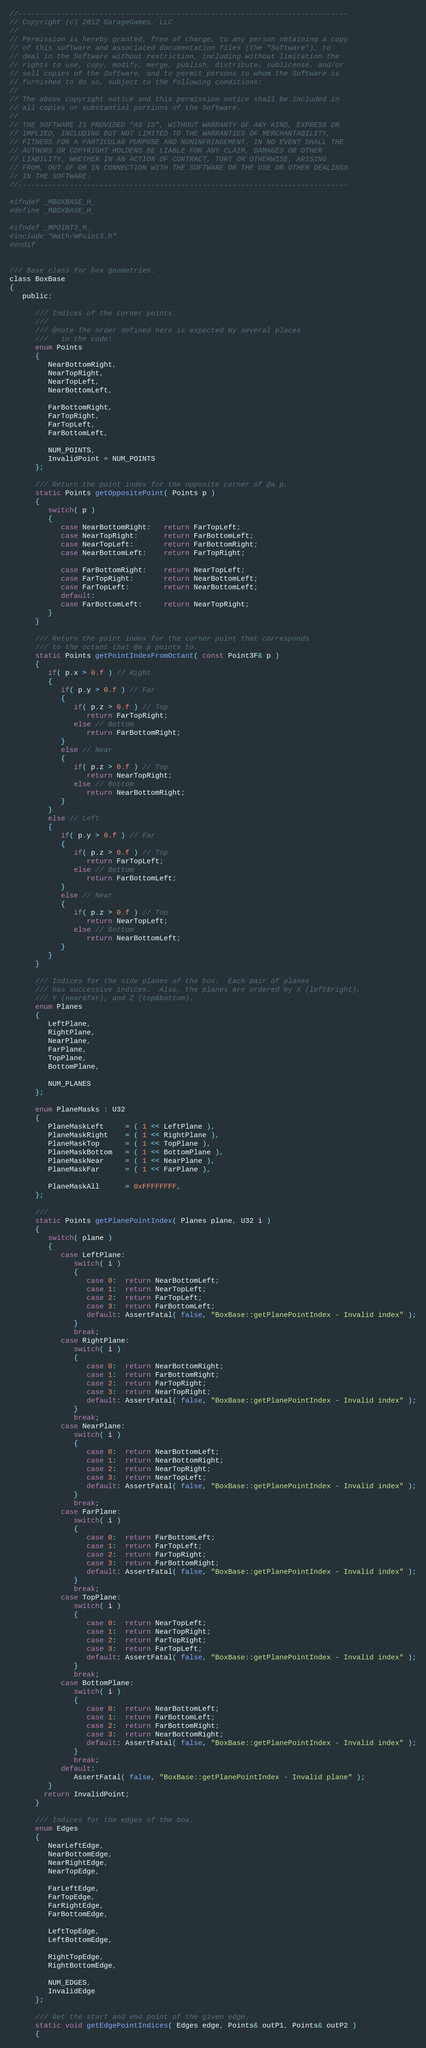Convert code to text. <code><loc_0><loc_0><loc_500><loc_500><_C_>//-----------------------------------------------------------------------------
// Copyright (c) 2012 GarageGames, LLC
//
// Permission is hereby granted, free of charge, to any person obtaining a copy
// of this software and associated documentation files (the "Software"), to
// deal in the Software without restriction, including without limitation the
// rights to use, copy, modify, merge, publish, distribute, sublicense, and/or
// sell copies of the Software, and to permit persons to whom the Software is
// furnished to do so, subject to the following conditions:
//
// The above copyright notice and this permission notice shall be included in
// all copies or substantial portions of the Software.
//
// THE SOFTWARE IS PROVIDED "AS IS", WITHOUT WARRANTY OF ANY KIND, EXPRESS OR
// IMPLIED, INCLUDING BUT NOT LIMITED TO THE WARRANTIES OF MERCHANTABILITY,
// FITNESS FOR A PARTICULAR PURPOSE AND NONINFRINGEMENT. IN NO EVENT SHALL THE
// AUTHORS OR COPYRIGHT HOLDERS BE LIABLE FOR ANY CLAIM, DAMAGES OR OTHER
// LIABILITY, WHETHER IN AN ACTION OF CONTRACT, TORT OR OTHERWISE, ARISING
// FROM, OUT OF OR IN CONNECTION WITH THE SOFTWARE OR THE USE OR OTHER DEALINGS
// IN THE SOFTWARE.
//-----------------------------------------------------------------------------

#ifndef _MBOXBASE_H_
#define _MBOXBASE_H_

#ifndef _MPOINT3_H_
#include "math/mPoint3.h"
#endif


/// Base class for box geometries.
class BoxBase
{
   public:

      /// Indices of the corner points.
      ///
      /// @note The order defined here is expected by several places
      ///   in the code!
      enum Points
      {
         NearBottomRight,
         NearTopRight,
         NearTopLeft,
         NearBottomLeft,

         FarBottomRight,
         FarTopRight,
         FarTopLeft,
         FarBottomLeft,

         NUM_POINTS,
		 InvalidPoint = NUM_POINTS
      };

      /// Return the point index for the opposite corner of @a p.
      static Points getOppositePoint( Points p )
      {
         switch( p )
         {
            case NearBottomRight:   return FarTopLeft;
            case NearTopRight:      return FarBottomLeft;
            case NearTopLeft:       return FarBottomRight;
            case NearBottomLeft:    return FarTopRight;

            case FarBottomRight:    return NearTopLeft;
            case FarTopRight:       return NearBottomLeft;
            case FarTopLeft:        return NearBottomLeft;
            default:
            case FarBottomLeft:     return NearTopRight;
         }
      }
       
      /// Return the point index for the corner point that corresponds
      /// to the octant that @a p points to.
      static Points getPointIndexFromOctant( const Point3F& p )
      {
         if( p.x > 0.f ) // Right
         {
            if( p.y > 0.f ) // Far
            {
               if( p.z > 0.f ) // Top
                  return FarTopRight;
               else // Bottom
                  return FarBottomRight;
            }
            else // Near
            {
               if( p.z > 0.f ) // Top
                  return NearTopRight;
               else // Bottom
                  return NearBottomRight;
            }
         }
         else // Left
         {
            if( p.y > 0.f ) // Far
            {
               if( p.z > 0.f ) // Top
                  return FarTopLeft;
               else // Bottom
                  return FarBottomLeft;
            }
            else // Near
            {
               if( p.z > 0.f ) // Top
                  return NearTopLeft;
               else // Bottom
                  return NearBottomLeft;
            }
         }
      }

      /// Indices for the side planes of the box.  Each pair of planes
      /// has successive indices.  Also, the planes are ordered by X (left&right),
      /// Y (near&far), and Z (top&bottom).
      enum Planes
      {
         LeftPlane,
         RightPlane,
         NearPlane,
         FarPlane,
         TopPlane,
         BottomPlane,

         NUM_PLANES
      };

      enum PlaneMasks : U32
      {
         PlaneMaskLeft     = ( 1 << LeftPlane ),
         PlaneMaskRight    = ( 1 << RightPlane ),
         PlaneMaskTop      = ( 1 << TopPlane ),
         PlaneMaskBottom   = ( 1 << BottomPlane ),
         PlaneMaskNear     = ( 1 << NearPlane ),
         PlaneMaskFar      = ( 1 << FarPlane ),

         PlaneMaskAll      = 0xFFFFFFFF,
      };

      ///
      static Points getPlanePointIndex( Planes plane, U32 i )
      {
         switch( plane )
         {
            case LeftPlane:
               switch( i )
               {
                  case 0:  return NearBottomLeft;
                  case 1:  return NearTopLeft;
                  case 2:  return FarTopLeft;
                  case 3:  return FarBottomLeft;
                  default: AssertFatal( false, "BoxBase::getPlanePointIndex - Invalid index" );
               }
               break;
            case RightPlane:
               switch( i )
               {
                  case 0:  return NearBottomRight;
                  case 1:  return FarBottomRight;
                  case 2:  return FarTopRight;
                  case 3:  return NearTopRight;
                  default: AssertFatal( false, "BoxBase::getPlanePointIndex - Invalid index" );
               }
               break;
            case NearPlane:
               switch( i )
               {
                  case 0:  return NearBottomLeft;
                  case 1:  return NearBottomRight;
                  case 2:  return NearTopRight;
                  case 3:  return NearTopLeft;
                  default: AssertFatal( false, "BoxBase::getPlanePointIndex - Invalid index" );
               }
               break;
            case FarPlane:
               switch( i )
               {
                  case 0:  return FarBottomLeft;
                  case 1:  return FarTopLeft;
                  case 2:  return FarTopRight;
                  case 3:  return FarBottomRight;
                  default: AssertFatal( false, "BoxBase::getPlanePointIndex - Invalid index" );
               }
               break;
            case TopPlane:
               switch( i )
               {
                  case 0:  return NearTopLeft;
                  case 1:  return NearTopRight;
                  case 2:  return FarTopRight;
                  case 3:  return FarTopLeft;
                  default: AssertFatal( false, "BoxBase::getPlanePointIndex - Invalid index" );
               }
               break;
            case BottomPlane:
               switch( i )
               {
                  case 0:  return NearBottomLeft;
                  case 1:  return FarBottomLeft;
                  case 2:  return FarBottomRight;
                  case 3:  return NearBottomRight;
                  default: AssertFatal( false, "BoxBase::getPlanePointIndex - Invalid index" );
               }
               break;
            default:
               AssertFatal( false, "BoxBase::getPlanePointIndex - Invalid plane" );
         }
        return InvalidPoint;
      }

      /// Indices for the edges of the box.
      enum Edges
      {
         NearLeftEdge,
         NearBottomEdge,
         NearRightEdge,
         NearTopEdge,

         FarLeftEdge,
         FarTopEdge,
         FarRightEdge,
         FarBottomEdge,

         LeftTopEdge,
         LeftBottomEdge,

         RightTopEdge,
         RightBottomEdge,

         NUM_EDGES,
         InvalidEdge
      };

      /// Get the start and end point of the given edge.
      static void getEdgePointIndices( Edges edge, Points& outP1, Points& outP2 )
      {</code> 